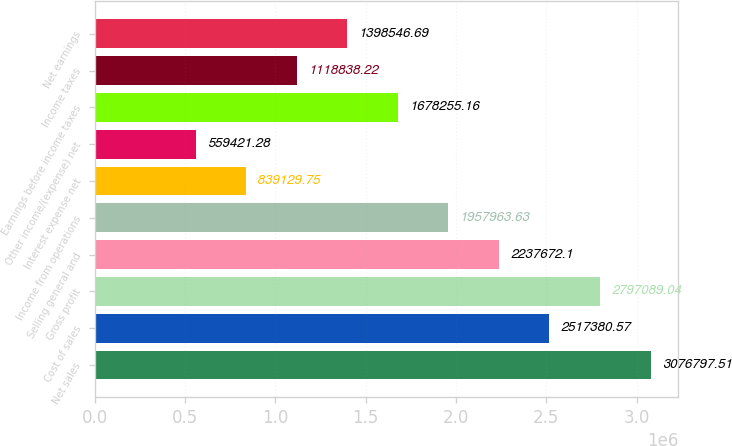<chart> <loc_0><loc_0><loc_500><loc_500><bar_chart><fcel>Net sales<fcel>Cost of sales<fcel>Gross profit<fcel>Selling general and<fcel>Income from operations<fcel>Interest expense net<fcel>Other income/(expense) net<fcel>Earnings before income taxes<fcel>Income taxes<fcel>Net earnings<nl><fcel>3.0768e+06<fcel>2.51738e+06<fcel>2.79709e+06<fcel>2.23767e+06<fcel>1.95796e+06<fcel>839130<fcel>559421<fcel>1.67826e+06<fcel>1.11884e+06<fcel>1.39855e+06<nl></chart> 